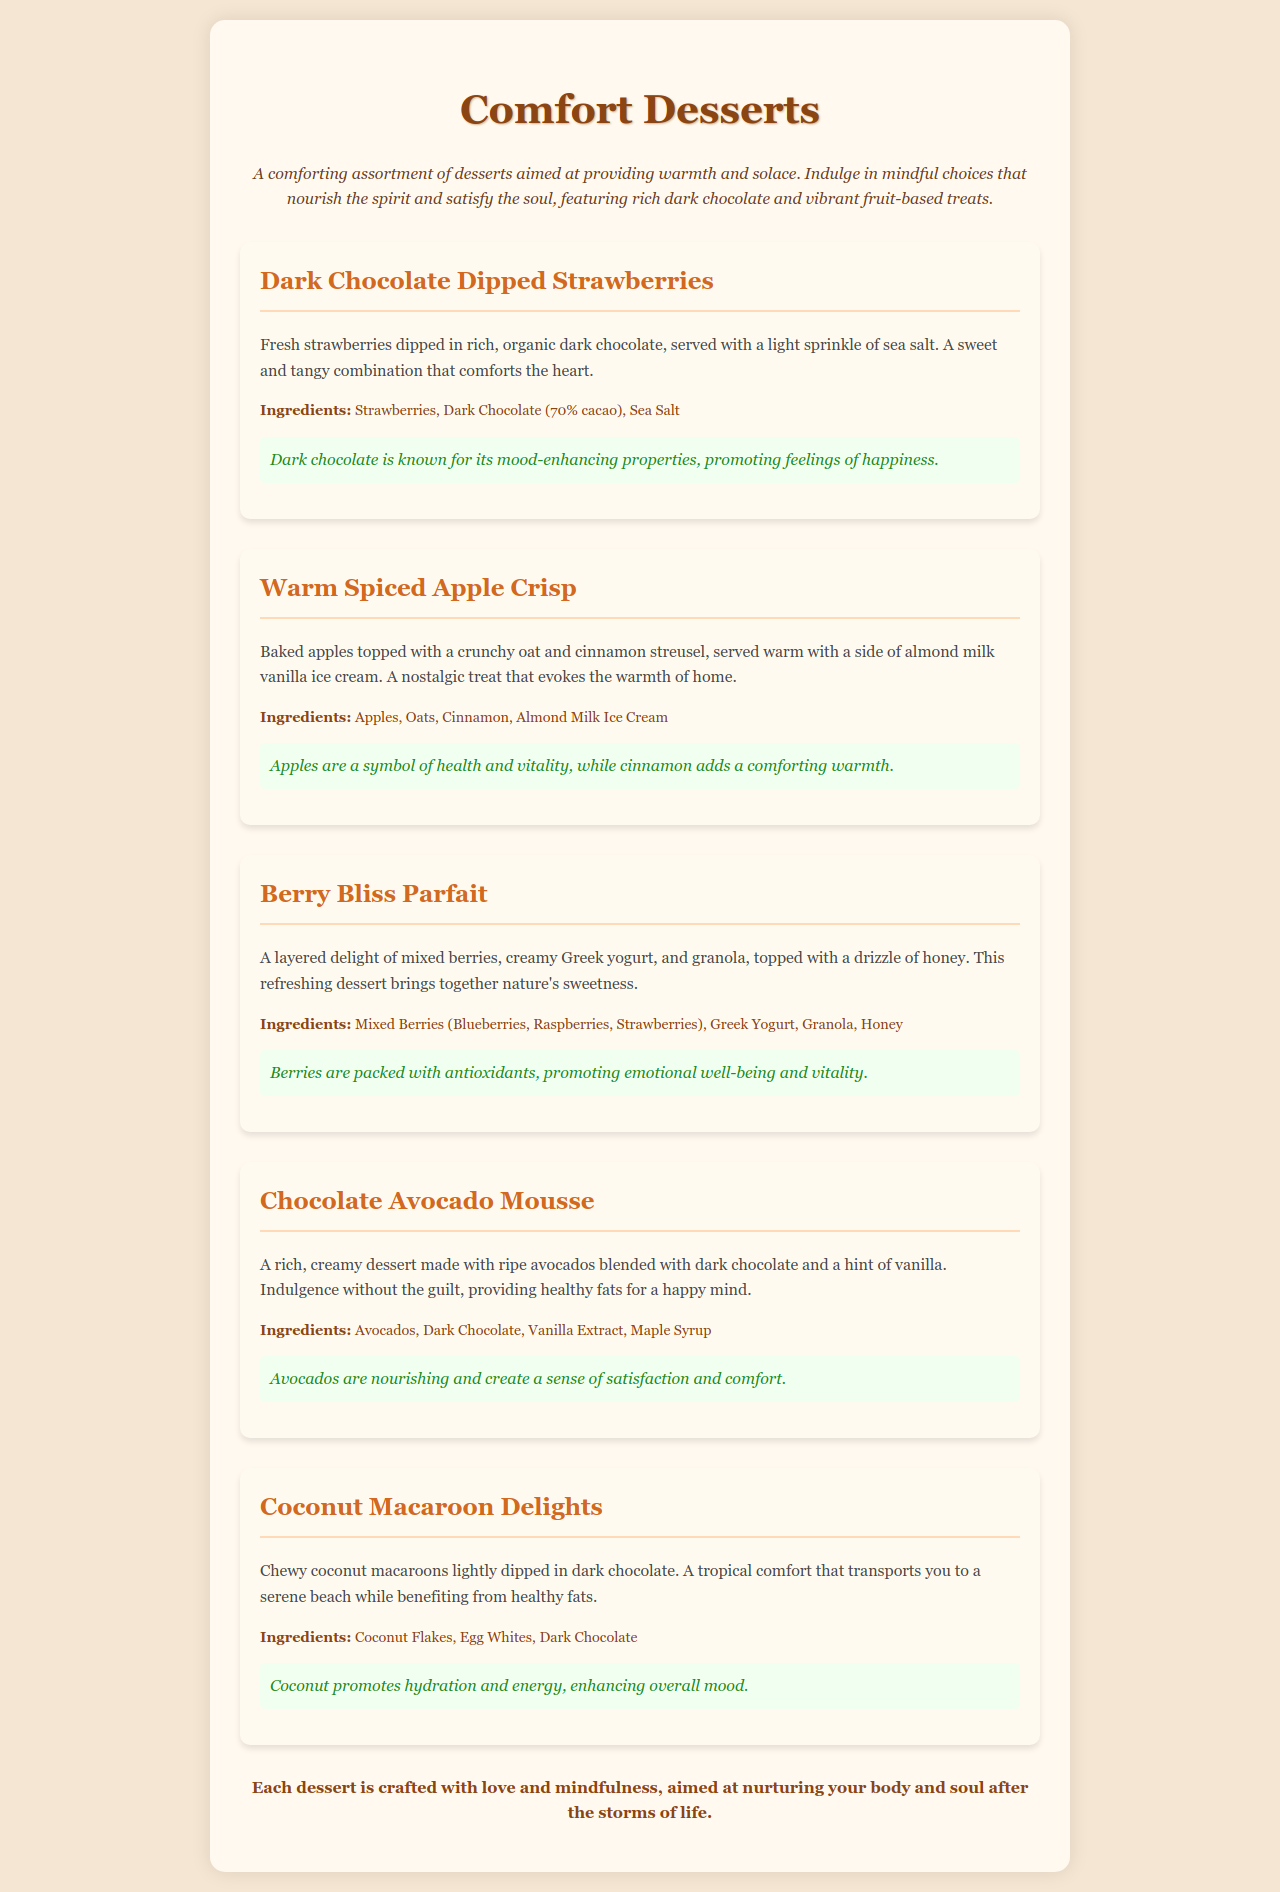What is the title of the menu? The title of the menu is prominently displayed at the top of the document.
Answer: Comfort Desserts How many menu items are listed? The document provides a clear overview of the number of items included in the menu.
Answer: Five What is the main ingredient in the Dark Chocolate Dipped Strawberries? The description of the menu item specifies the primary ingredient used in this dessert.
Answer: Strawberries What type of ice cream is served with the Warm Spiced Apple Crisp? The ingredients section details the specific type of ice cream paired with this dessert.
Answer: Almond Milk Vanilla Ice Cream What does the Chocolate Avocado Mousse aim to provide? The description of the dessert outlines its intended effect on the consumer.
Answer: Healthy fats for a happy mind Which ingredient is common in the Coconut Macaroon Delights? The ingredients list for this dessert indicates a repeated key component.
Answer: Coconut Flakes What is the mood-enhancing property of dark chocolate mentioned in the menu? The mindfulness note addresses the effect of dark chocolate on the consumer's emotions.
Answer: Promoting feelings of happiness What type of milk is used in the Warm Spiced Apple Crisp? The ingredients section specifically states the kind of milk accompanying this dessert.
Answer: Almond Milk Which dessert features a layering of mixed berries? The menu clearly describes one dessert that includes this combination of ingredients.
Answer: Berry Bliss Parfait 